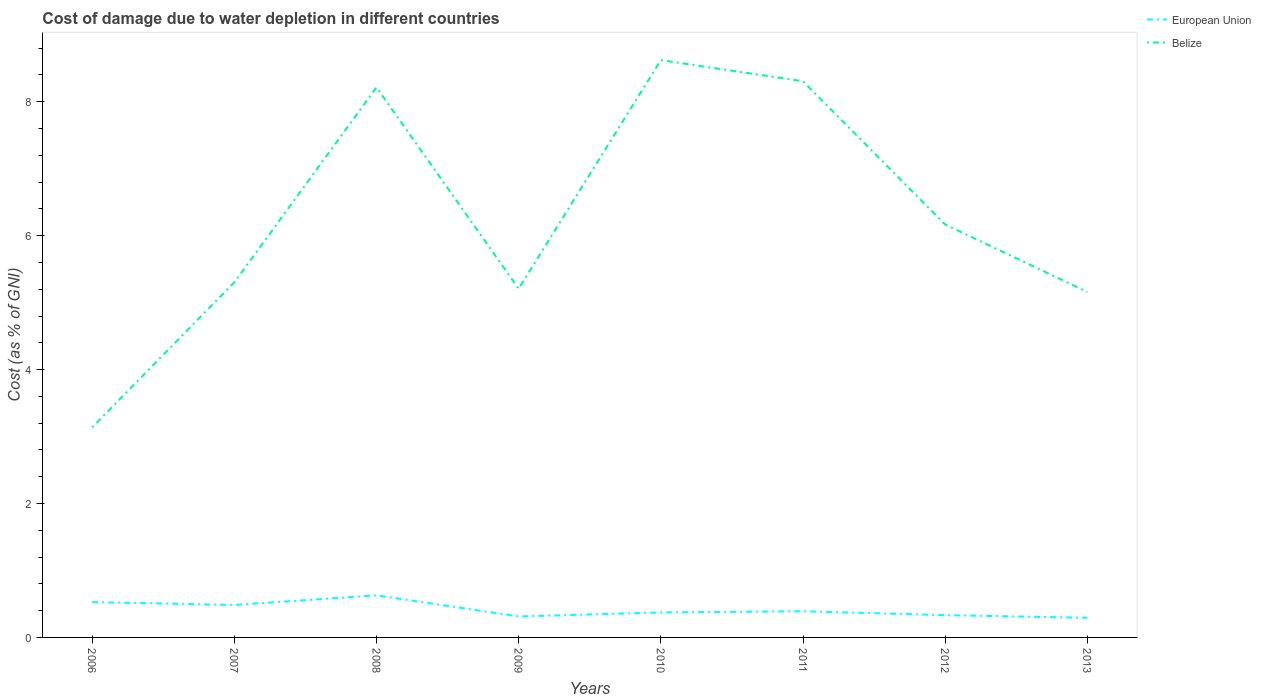How many different coloured lines are there?
Offer a very short reply. 2. Does the line corresponding to Belize intersect with the line corresponding to European Union?
Ensure brevity in your answer.  No. Across all years, what is the maximum cost of damage caused due to water depletion in Belize?
Ensure brevity in your answer.  3.14. What is the total cost of damage caused due to water depletion in Belize in the graph?
Your response must be concise. -0.41. What is the difference between the highest and the second highest cost of damage caused due to water depletion in European Union?
Offer a terse response. 0.34. What is the difference between the highest and the lowest cost of damage caused due to water depletion in Belize?
Give a very brief answer. 3. Is the cost of damage caused due to water depletion in Belize strictly greater than the cost of damage caused due to water depletion in European Union over the years?
Provide a succinct answer. No. How many lines are there?
Give a very brief answer. 2. How many years are there in the graph?
Give a very brief answer. 8. What is the difference between two consecutive major ticks on the Y-axis?
Offer a terse response. 2. Are the values on the major ticks of Y-axis written in scientific E-notation?
Make the answer very short. No. How many legend labels are there?
Offer a terse response. 2. How are the legend labels stacked?
Provide a short and direct response. Vertical. What is the title of the graph?
Provide a short and direct response. Cost of damage due to water depletion in different countries. Does "St. Vincent and the Grenadines" appear as one of the legend labels in the graph?
Your answer should be compact. No. What is the label or title of the X-axis?
Keep it short and to the point. Years. What is the label or title of the Y-axis?
Your response must be concise. Cost (as % of GNI). What is the Cost (as % of GNI) of European Union in 2006?
Make the answer very short. 0.53. What is the Cost (as % of GNI) in Belize in 2006?
Keep it short and to the point. 3.14. What is the Cost (as % of GNI) of European Union in 2007?
Give a very brief answer. 0.48. What is the Cost (as % of GNI) of Belize in 2007?
Your answer should be compact. 5.3. What is the Cost (as % of GNI) of European Union in 2008?
Give a very brief answer. 0.63. What is the Cost (as % of GNI) of Belize in 2008?
Offer a terse response. 8.21. What is the Cost (as % of GNI) of European Union in 2009?
Provide a short and direct response. 0.31. What is the Cost (as % of GNI) in Belize in 2009?
Give a very brief answer. 5.21. What is the Cost (as % of GNI) of European Union in 2010?
Offer a terse response. 0.37. What is the Cost (as % of GNI) of Belize in 2010?
Offer a very short reply. 8.62. What is the Cost (as % of GNI) of European Union in 2011?
Offer a very short reply. 0.39. What is the Cost (as % of GNI) in Belize in 2011?
Keep it short and to the point. 8.31. What is the Cost (as % of GNI) in European Union in 2012?
Offer a terse response. 0.33. What is the Cost (as % of GNI) in Belize in 2012?
Provide a succinct answer. 6.17. What is the Cost (as % of GNI) in European Union in 2013?
Your answer should be compact. 0.29. What is the Cost (as % of GNI) in Belize in 2013?
Offer a very short reply. 5.16. Across all years, what is the maximum Cost (as % of GNI) in European Union?
Your answer should be very brief. 0.63. Across all years, what is the maximum Cost (as % of GNI) of Belize?
Your answer should be compact. 8.62. Across all years, what is the minimum Cost (as % of GNI) in European Union?
Offer a terse response. 0.29. Across all years, what is the minimum Cost (as % of GNI) in Belize?
Provide a succinct answer. 3.14. What is the total Cost (as % of GNI) in European Union in the graph?
Offer a terse response. 3.34. What is the total Cost (as % of GNI) of Belize in the graph?
Your answer should be compact. 50.12. What is the difference between the Cost (as % of GNI) in European Union in 2006 and that in 2007?
Keep it short and to the point. 0.04. What is the difference between the Cost (as % of GNI) in Belize in 2006 and that in 2007?
Your answer should be very brief. -2.17. What is the difference between the Cost (as % of GNI) of European Union in 2006 and that in 2008?
Give a very brief answer. -0.1. What is the difference between the Cost (as % of GNI) of Belize in 2006 and that in 2008?
Your answer should be very brief. -5.08. What is the difference between the Cost (as % of GNI) in European Union in 2006 and that in 2009?
Your answer should be very brief. 0.21. What is the difference between the Cost (as % of GNI) in Belize in 2006 and that in 2009?
Offer a very short reply. -2.07. What is the difference between the Cost (as % of GNI) in European Union in 2006 and that in 2010?
Provide a short and direct response. 0.15. What is the difference between the Cost (as % of GNI) in Belize in 2006 and that in 2010?
Make the answer very short. -5.48. What is the difference between the Cost (as % of GNI) in European Union in 2006 and that in 2011?
Your answer should be very brief. 0.14. What is the difference between the Cost (as % of GNI) of Belize in 2006 and that in 2011?
Make the answer very short. -5.17. What is the difference between the Cost (as % of GNI) of European Union in 2006 and that in 2012?
Your answer should be compact. 0.19. What is the difference between the Cost (as % of GNI) in Belize in 2006 and that in 2012?
Your answer should be compact. -3.03. What is the difference between the Cost (as % of GNI) of European Union in 2006 and that in 2013?
Provide a succinct answer. 0.23. What is the difference between the Cost (as % of GNI) in Belize in 2006 and that in 2013?
Provide a succinct answer. -2.02. What is the difference between the Cost (as % of GNI) in European Union in 2007 and that in 2008?
Keep it short and to the point. -0.14. What is the difference between the Cost (as % of GNI) in Belize in 2007 and that in 2008?
Offer a very short reply. -2.91. What is the difference between the Cost (as % of GNI) in European Union in 2007 and that in 2009?
Ensure brevity in your answer.  0.17. What is the difference between the Cost (as % of GNI) in Belize in 2007 and that in 2009?
Make the answer very short. 0.1. What is the difference between the Cost (as % of GNI) of European Union in 2007 and that in 2010?
Your response must be concise. 0.11. What is the difference between the Cost (as % of GNI) in Belize in 2007 and that in 2010?
Give a very brief answer. -3.32. What is the difference between the Cost (as % of GNI) of European Union in 2007 and that in 2011?
Give a very brief answer. 0.09. What is the difference between the Cost (as % of GNI) of Belize in 2007 and that in 2011?
Your answer should be very brief. -3. What is the difference between the Cost (as % of GNI) of European Union in 2007 and that in 2012?
Your answer should be very brief. 0.15. What is the difference between the Cost (as % of GNI) in Belize in 2007 and that in 2012?
Provide a succinct answer. -0.86. What is the difference between the Cost (as % of GNI) in European Union in 2007 and that in 2013?
Offer a terse response. 0.19. What is the difference between the Cost (as % of GNI) of Belize in 2007 and that in 2013?
Your response must be concise. 0.14. What is the difference between the Cost (as % of GNI) in European Union in 2008 and that in 2009?
Ensure brevity in your answer.  0.32. What is the difference between the Cost (as % of GNI) in Belize in 2008 and that in 2009?
Ensure brevity in your answer.  3.01. What is the difference between the Cost (as % of GNI) of European Union in 2008 and that in 2010?
Make the answer very short. 0.26. What is the difference between the Cost (as % of GNI) in Belize in 2008 and that in 2010?
Provide a short and direct response. -0.41. What is the difference between the Cost (as % of GNI) of European Union in 2008 and that in 2011?
Provide a succinct answer. 0.24. What is the difference between the Cost (as % of GNI) in Belize in 2008 and that in 2011?
Offer a terse response. -0.09. What is the difference between the Cost (as % of GNI) of European Union in 2008 and that in 2012?
Offer a very short reply. 0.3. What is the difference between the Cost (as % of GNI) of Belize in 2008 and that in 2012?
Offer a very short reply. 2.05. What is the difference between the Cost (as % of GNI) in European Union in 2008 and that in 2013?
Offer a very short reply. 0.34. What is the difference between the Cost (as % of GNI) in Belize in 2008 and that in 2013?
Provide a succinct answer. 3.05. What is the difference between the Cost (as % of GNI) in European Union in 2009 and that in 2010?
Keep it short and to the point. -0.06. What is the difference between the Cost (as % of GNI) of Belize in 2009 and that in 2010?
Your response must be concise. -3.41. What is the difference between the Cost (as % of GNI) of European Union in 2009 and that in 2011?
Offer a very short reply. -0.08. What is the difference between the Cost (as % of GNI) in Belize in 2009 and that in 2011?
Provide a short and direct response. -3.1. What is the difference between the Cost (as % of GNI) of European Union in 2009 and that in 2012?
Make the answer very short. -0.02. What is the difference between the Cost (as % of GNI) in Belize in 2009 and that in 2012?
Your answer should be compact. -0.96. What is the difference between the Cost (as % of GNI) in European Union in 2009 and that in 2013?
Provide a short and direct response. 0.02. What is the difference between the Cost (as % of GNI) in Belize in 2009 and that in 2013?
Keep it short and to the point. 0.05. What is the difference between the Cost (as % of GNI) in European Union in 2010 and that in 2011?
Make the answer very short. -0.02. What is the difference between the Cost (as % of GNI) of Belize in 2010 and that in 2011?
Offer a very short reply. 0.32. What is the difference between the Cost (as % of GNI) of Belize in 2010 and that in 2012?
Provide a succinct answer. 2.45. What is the difference between the Cost (as % of GNI) in Belize in 2010 and that in 2013?
Ensure brevity in your answer.  3.46. What is the difference between the Cost (as % of GNI) in European Union in 2011 and that in 2012?
Your response must be concise. 0.06. What is the difference between the Cost (as % of GNI) in Belize in 2011 and that in 2012?
Provide a succinct answer. 2.14. What is the difference between the Cost (as % of GNI) of European Union in 2011 and that in 2013?
Provide a succinct answer. 0.1. What is the difference between the Cost (as % of GNI) of Belize in 2011 and that in 2013?
Your response must be concise. 3.15. What is the difference between the Cost (as % of GNI) in European Union in 2012 and that in 2013?
Make the answer very short. 0.04. What is the difference between the Cost (as % of GNI) of Belize in 2012 and that in 2013?
Make the answer very short. 1.01. What is the difference between the Cost (as % of GNI) of European Union in 2006 and the Cost (as % of GNI) of Belize in 2007?
Your response must be concise. -4.78. What is the difference between the Cost (as % of GNI) in European Union in 2006 and the Cost (as % of GNI) in Belize in 2008?
Ensure brevity in your answer.  -7.69. What is the difference between the Cost (as % of GNI) of European Union in 2006 and the Cost (as % of GNI) of Belize in 2009?
Your answer should be compact. -4.68. What is the difference between the Cost (as % of GNI) in European Union in 2006 and the Cost (as % of GNI) in Belize in 2010?
Your response must be concise. -8.09. What is the difference between the Cost (as % of GNI) in European Union in 2006 and the Cost (as % of GNI) in Belize in 2011?
Provide a short and direct response. -7.78. What is the difference between the Cost (as % of GNI) in European Union in 2006 and the Cost (as % of GNI) in Belize in 2012?
Ensure brevity in your answer.  -5.64. What is the difference between the Cost (as % of GNI) in European Union in 2006 and the Cost (as % of GNI) in Belize in 2013?
Offer a terse response. -4.63. What is the difference between the Cost (as % of GNI) in European Union in 2007 and the Cost (as % of GNI) in Belize in 2008?
Offer a terse response. -7.73. What is the difference between the Cost (as % of GNI) in European Union in 2007 and the Cost (as % of GNI) in Belize in 2009?
Offer a very short reply. -4.72. What is the difference between the Cost (as % of GNI) of European Union in 2007 and the Cost (as % of GNI) of Belize in 2010?
Provide a short and direct response. -8.14. What is the difference between the Cost (as % of GNI) in European Union in 2007 and the Cost (as % of GNI) in Belize in 2011?
Offer a terse response. -7.82. What is the difference between the Cost (as % of GNI) in European Union in 2007 and the Cost (as % of GNI) in Belize in 2012?
Offer a terse response. -5.68. What is the difference between the Cost (as % of GNI) of European Union in 2007 and the Cost (as % of GNI) of Belize in 2013?
Provide a succinct answer. -4.67. What is the difference between the Cost (as % of GNI) of European Union in 2008 and the Cost (as % of GNI) of Belize in 2009?
Provide a short and direct response. -4.58. What is the difference between the Cost (as % of GNI) in European Union in 2008 and the Cost (as % of GNI) in Belize in 2010?
Offer a terse response. -7.99. What is the difference between the Cost (as % of GNI) of European Union in 2008 and the Cost (as % of GNI) of Belize in 2011?
Ensure brevity in your answer.  -7.68. What is the difference between the Cost (as % of GNI) in European Union in 2008 and the Cost (as % of GNI) in Belize in 2012?
Offer a very short reply. -5.54. What is the difference between the Cost (as % of GNI) in European Union in 2008 and the Cost (as % of GNI) in Belize in 2013?
Offer a very short reply. -4.53. What is the difference between the Cost (as % of GNI) in European Union in 2009 and the Cost (as % of GNI) in Belize in 2010?
Provide a succinct answer. -8.31. What is the difference between the Cost (as % of GNI) of European Union in 2009 and the Cost (as % of GNI) of Belize in 2011?
Your answer should be very brief. -7.99. What is the difference between the Cost (as % of GNI) of European Union in 2009 and the Cost (as % of GNI) of Belize in 2012?
Keep it short and to the point. -5.85. What is the difference between the Cost (as % of GNI) of European Union in 2009 and the Cost (as % of GNI) of Belize in 2013?
Offer a terse response. -4.85. What is the difference between the Cost (as % of GNI) in European Union in 2010 and the Cost (as % of GNI) in Belize in 2011?
Offer a terse response. -7.93. What is the difference between the Cost (as % of GNI) in European Union in 2010 and the Cost (as % of GNI) in Belize in 2012?
Ensure brevity in your answer.  -5.79. What is the difference between the Cost (as % of GNI) in European Union in 2010 and the Cost (as % of GNI) in Belize in 2013?
Make the answer very short. -4.79. What is the difference between the Cost (as % of GNI) of European Union in 2011 and the Cost (as % of GNI) of Belize in 2012?
Give a very brief answer. -5.78. What is the difference between the Cost (as % of GNI) of European Union in 2011 and the Cost (as % of GNI) of Belize in 2013?
Your response must be concise. -4.77. What is the difference between the Cost (as % of GNI) in European Union in 2012 and the Cost (as % of GNI) in Belize in 2013?
Make the answer very short. -4.83. What is the average Cost (as % of GNI) in European Union per year?
Offer a very short reply. 0.42. What is the average Cost (as % of GNI) of Belize per year?
Your answer should be compact. 6.26. In the year 2006, what is the difference between the Cost (as % of GNI) in European Union and Cost (as % of GNI) in Belize?
Provide a short and direct response. -2.61. In the year 2007, what is the difference between the Cost (as % of GNI) in European Union and Cost (as % of GNI) in Belize?
Provide a succinct answer. -4.82. In the year 2008, what is the difference between the Cost (as % of GNI) in European Union and Cost (as % of GNI) in Belize?
Provide a short and direct response. -7.59. In the year 2009, what is the difference between the Cost (as % of GNI) of European Union and Cost (as % of GNI) of Belize?
Your answer should be compact. -4.89. In the year 2010, what is the difference between the Cost (as % of GNI) of European Union and Cost (as % of GNI) of Belize?
Ensure brevity in your answer.  -8.25. In the year 2011, what is the difference between the Cost (as % of GNI) of European Union and Cost (as % of GNI) of Belize?
Your response must be concise. -7.91. In the year 2012, what is the difference between the Cost (as % of GNI) of European Union and Cost (as % of GNI) of Belize?
Your answer should be very brief. -5.83. In the year 2013, what is the difference between the Cost (as % of GNI) of European Union and Cost (as % of GNI) of Belize?
Your answer should be compact. -4.87. What is the ratio of the Cost (as % of GNI) in European Union in 2006 to that in 2007?
Keep it short and to the point. 1.09. What is the ratio of the Cost (as % of GNI) of Belize in 2006 to that in 2007?
Keep it short and to the point. 0.59. What is the ratio of the Cost (as % of GNI) in European Union in 2006 to that in 2008?
Your answer should be very brief. 0.84. What is the ratio of the Cost (as % of GNI) in Belize in 2006 to that in 2008?
Your answer should be compact. 0.38. What is the ratio of the Cost (as % of GNI) in European Union in 2006 to that in 2009?
Give a very brief answer. 1.68. What is the ratio of the Cost (as % of GNI) in Belize in 2006 to that in 2009?
Offer a very short reply. 0.6. What is the ratio of the Cost (as % of GNI) of European Union in 2006 to that in 2010?
Your response must be concise. 1.41. What is the ratio of the Cost (as % of GNI) in Belize in 2006 to that in 2010?
Keep it short and to the point. 0.36. What is the ratio of the Cost (as % of GNI) in European Union in 2006 to that in 2011?
Give a very brief answer. 1.35. What is the ratio of the Cost (as % of GNI) of Belize in 2006 to that in 2011?
Your answer should be compact. 0.38. What is the ratio of the Cost (as % of GNI) of European Union in 2006 to that in 2012?
Provide a short and direct response. 1.58. What is the ratio of the Cost (as % of GNI) in Belize in 2006 to that in 2012?
Your response must be concise. 0.51. What is the ratio of the Cost (as % of GNI) in European Union in 2006 to that in 2013?
Your answer should be very brief. 1.8. What is the ratio of the Cost (as % of GNI) in Belize in 2006 to that in 2013?
Offer a very short reply. 0.61. What is the ratio of the Cost (as % of GNI) in European Union in 2007 to that in 2008?
Offer a very short reply. 0.77. What is the ratio of the Cost (as % of GNI) of Belize in 2007 to that in 2008?
Offer a terse response. 0.65. What is the ratio of the Cost (as % of GNI) of European Union in 2007 to that in 2009?
Ensure brevity in your answer.  1.55. What is the ratio of the Cost (as % of GNI) in Belize in 2007 to that in 2009?
Provide a succinct answer. 1.02. What is the ratio of the Cost (as % of GNI) of European Union in 2007 to that in 2010?
Ensure brevity in your answer.  1.3. What is the ratio of the Cost (as % of GNI) of Belize in 2007 to that in 2010?
Your answer should be very brief. 0.62. What is the ratio of the Cost (as % of GNI) of European Union in 2007 to that in 2011?
Offer a terse response. 1.24. What is the ratio of the Cost (as % of GNI) of Belize in 2007 to that in 2011?
Your answer should be compact. 0.64. What is the ratio of the Cost (as % of GNI) in European Union in 2007 to that in 2012?
Your answer should be very brief. 1.46. What is the ratio of the Cost (as % of GNI) in Belize in 2007 to that in 2012?
Offer a very short reply. 0.86. What is the ratio of the Cost (as % of GNI) of European Union in 2007 to that in 2013?
Provide a succinct answer. 1.65. What is the ratio of the Cost (as % of GNI) of Belize in 2007 to that in 2013?
Keep it short and to the point. 1.03. What is the ratio of the Cost (as % of GNI) in European Union in 2008 to that in 2009?
Make the answer very short. 2.01. What is the ratio of the Cost (as % of GNI) of Belize in 2008 to that in 2009?
Offer a terse response. 1.58. What is the ratio of the Cost (as % of GNI) of European Union in 2008 to that in 2010?
Offer a very short reply. 1.69. What is the ratio of the Cost (as % of GNI) of Belize in 2008 to that in 2010?
Provide a succinct answer. 0.95. What is the ratio of the Cost (as % of GNI) of European Union in 2008 to that in 2011?
Give a very brief answer. 1.61. What is the ratio of the Cost (as % of GNI) in European Union in 2008 to that in 2012?
Make the answer very short. 1.89. What is the ratio of the Cost (as % of GNI) of Belize in 2008 to that in 2012?
Your response must be concise. 1.33. What is the ratio of the Cost (as % of GNI) of European Union in 2008 to that in 2013?
Give a very brief answer. 2.15. What is the ratio of the Cost (as % of GNI) of Belize in 2008 to that in 2013?
Provide a short and direct response. 1.59. What is the ratio of the Cost (as % of GNI) of European Union in 2009 to that in 2010?
Ensure brevity in your answer.  0.84. What is the ratio of the Cost (as % of GNI) of Belize in 2009 to that in 2010?
Your response must be concise. 0.6. What is the ratio of the Cost (as % of GNI) of European Union in 2009 to that in 2011?
Offer a very short reply. 0.8. What is the ratio of the Cost (as % of GNI) in Belize in 2009 to that in 2011?
Your response must be concise. 0.63. What is the ratio of the Cost (as % of GNI) in European Union in 2009 to that in 2012?
Your answer should be compact. 0.94. What is the ratio of the Cost (as % of GNI) in Belize in 2009 to that in 2012?
Provide a succinct answer. 0.84. What is the ratio of the Cost (as % of GNI) in European Union in 2009 to that in 2013?
Make the answer very short. 1.07. What is the ratio of the Cost (as % of GNI) of Belize in 2009 to that in 2013?
Make the answer very short. 1.01. What is the ratio of the Cost (as % of GNI) in European Union in 2010 to that in 2011?
Provide a succinct answer. 0.95. What is the ratio of the Cost (as % of GNI) in Belize in 2010 to that in 2011?
Your answer should be very brief. 1.04. What is the ratio of the Cost (as % of GNI) in European Union in 2010 to that in 2012?
Provide a succinct answer. 1.12. What is the ratio of the Cost (as % of GNI) in Belize in 2010 to that in 2012?
Ensure brevity in your answer.  1.4. What is the ratio of the Cost (as % of GNI) of European Union in 2010 to that in 2013?
Your answer should be compact. 1.27. What is the ratio of the Cost (as % of GNI) in Belize in 2010 to that in 2013?
Provide a short and direct response. 1.67. What is the ratio of the Cost (as % of GNI) in European Union in 2011 to that in 2012?
Your answer should be compact. 1.17. What is the ratio of the Cost (as % of GNI) of Belize in 2011 to that in 2012?
Provide a short and direct response. 1.35. What is the ratio of the Cost (as % of GNI) of European Union in 2011 to that in 2013?
Your answer should be very brief. 1.33. What is the ratio of the Cost (as % of GNI) of Belize in 2011 to that in 2013?
Provide a short and direct response. 1.61. What is the ratio of the Cost (as % of GNI) of European Union in 2012 to that in 2013?
Provide a succinct answer. 1.14. What is the ratio of the Cost (as % of GNI) of Belize in 2012 to that in 2013?
Make the answer very short. 1.2. What is the difference between the highest and the second highest Cost (as % of GNI) of European Union?
Offer a very short reply. 0.1. What is the difference between the highest and the second highest Cost (as % of GNI) in Belize?
Offer a very short reply. 0.32. What is the difference between the highest and the lowest Cost (as % of GNI) in European Union?
Your answer should be very brief. 0.34. What is the difference between the highest and the lowest Cost (as % of GNI) in Belize?
Your answer should be very brief. 5.48. 